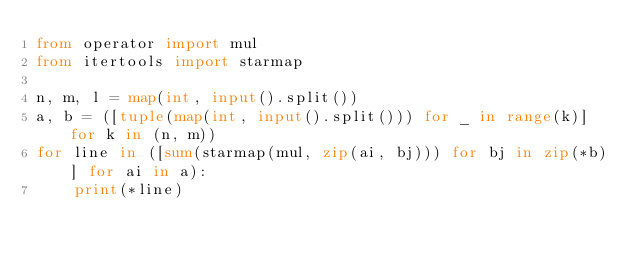Convert code to text. <code><loc_0><loc_0><loc_500><loc_500><_Python_>from operator import mul
from itertools import starmap
 
n, m, l = map(int, input().split())
a, b = ([tuple(map(int, input().split())) for _ in range(k)] for k in (n, m))
for line in ([sum(starmap(mul, zip(ai, bj))) for bj in zip(*b)] for ai in a):
    print(*line)</code> 